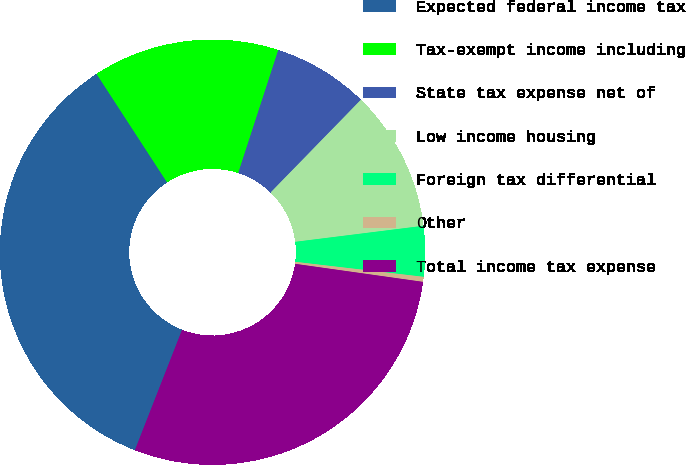Convert chart to OTSL. <chart><loc_0><loc_0><loc_500><loc_500><pie_chart><fcel>Expected federal income tax<fcel>Tax-exempt income including<fcel>State tax expense net of<fcel>Low income housing<fcel>Foreign tax differential<fcel>Other<fcel>Total income tax expense<nl><fcel>34.88%<fcel>14.18%<fcel>7.28%<fcel>10.73%<fcel>3.83%<fcel>0.38%<fcel>28.71%<nl></chart> 